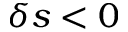<formula> <loc_0><loc_0><loc_500><loc_500>\delta s < 0</formula> 